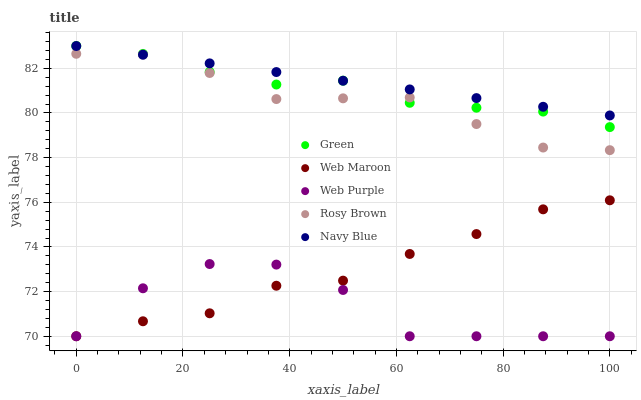Does Web Purple have the minimum area under the curve?
Answer yes or no. Yes. Does Navy Blue have the maximum area under the curve?
Answer yes or no. Yes. Does Rosy Brown have the minimum area under the curve?
Answer yes or no. No. Does Rosy Brown have the maximum area under the curve?
Answer yes or no. No. Is Navy Blue the smoothest?
Answer yes or no. Yes. Is Web Purple the roughest?
Answer yes or no. Yes. Is Rosy Brown the smoothest?
Answer yes or no. No. Is Rosy Brown the roughest?
Answer yes or no. No. Does Web Maroon have the lowest value?
Answer yes or no. Yes. Does Rosy Brown have the lowest value?
Answer yes or no. No. Does Navy Blue have the highest value?
Answer yes or no. Yes. Does Rosy Brown have the highest value?
Answer yes or no. No. Is Web Purple less than Navy Blue?
Answer yes or no. Yes. Is Navy Blue greater than Web Maroon?
Answer yes or no. Yes. Does Rosy Brown intersect Green?
Answer yes or no. Yes. Is Rosy Brown less than Green?
Answer yes or no. No. Is Rosy Brown greater than Green?
Answer yes or no. No. Does Web Purple intersect Navy Blue?
Answer yes or no. No. 